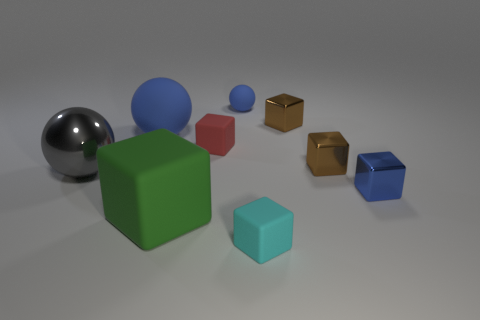Which objects in the image share the same shape? In this composition, the cubes share a kindred geometry, each with six faces meeting at sharp right angles. 